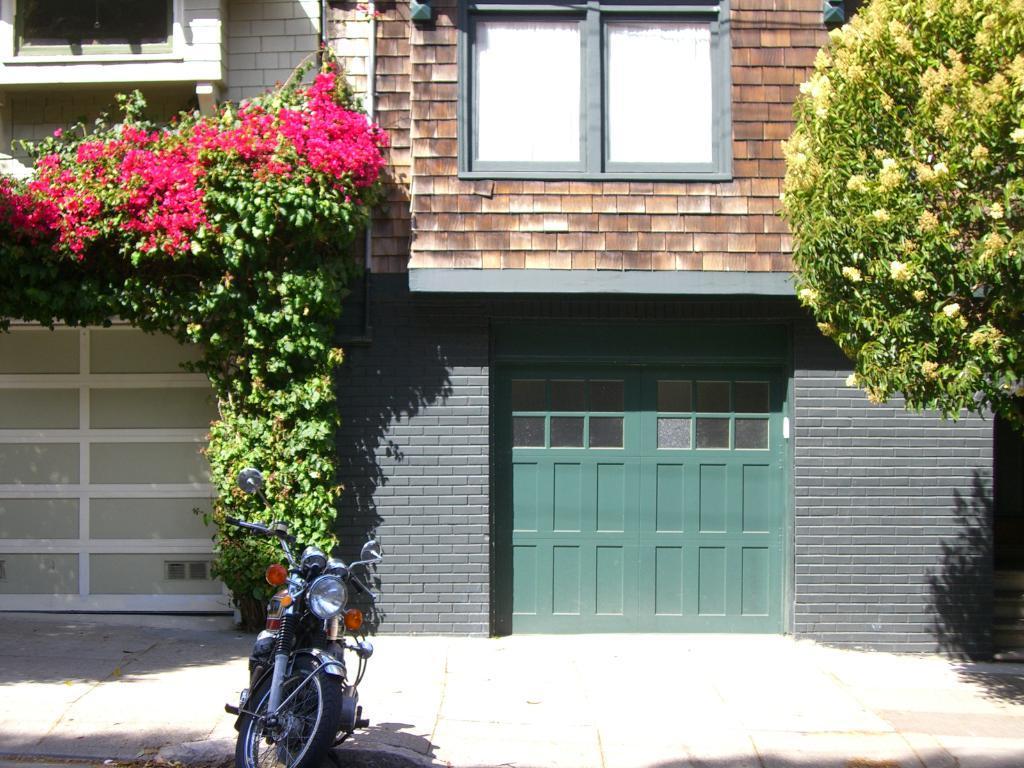Describe this image in one or two sentences. In this image we can see a motorcycle and in the background of the image there are some plants, trees to which some flowers are grown, there are some buildings. 